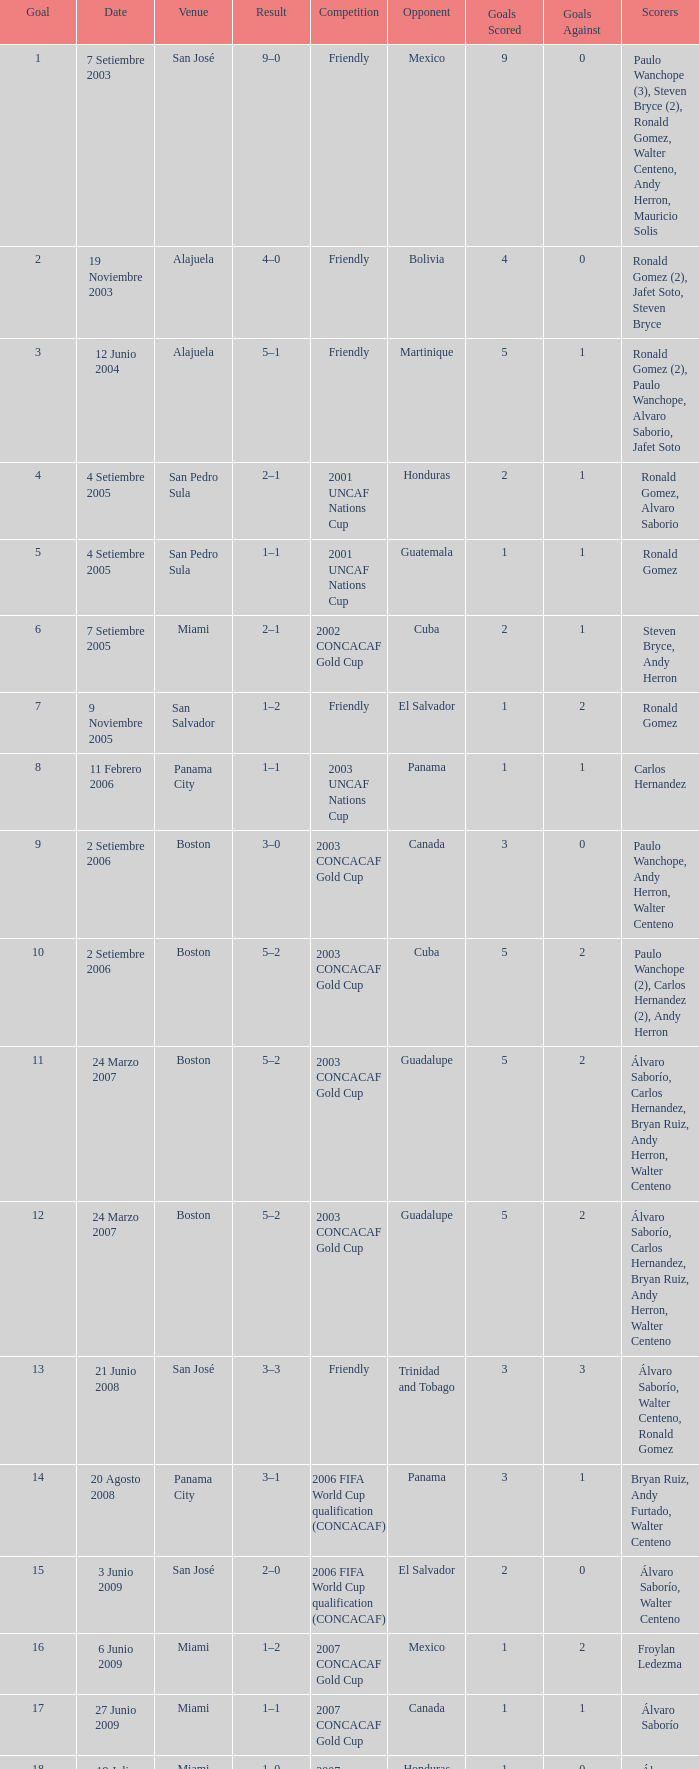How was the competition in which 6 goals were made? 2002 CONCACAF Gold Cup. 